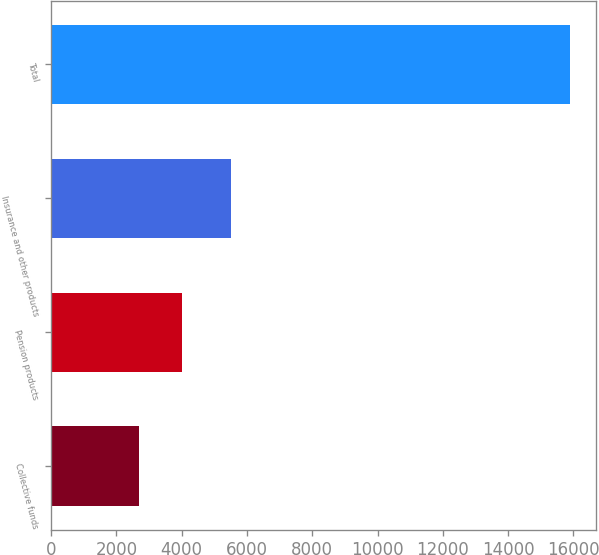Convert chart. <chart><loc_0><loc_0><loc_500><loc_500><bar_chart><fcel>Collective funds<fcel>Pension products<fcel>Insurance and other products<fcel>Total<nl><fcel>2679<fcel>4001.8<fcel>5514<fcel>15907<nl></chart> 